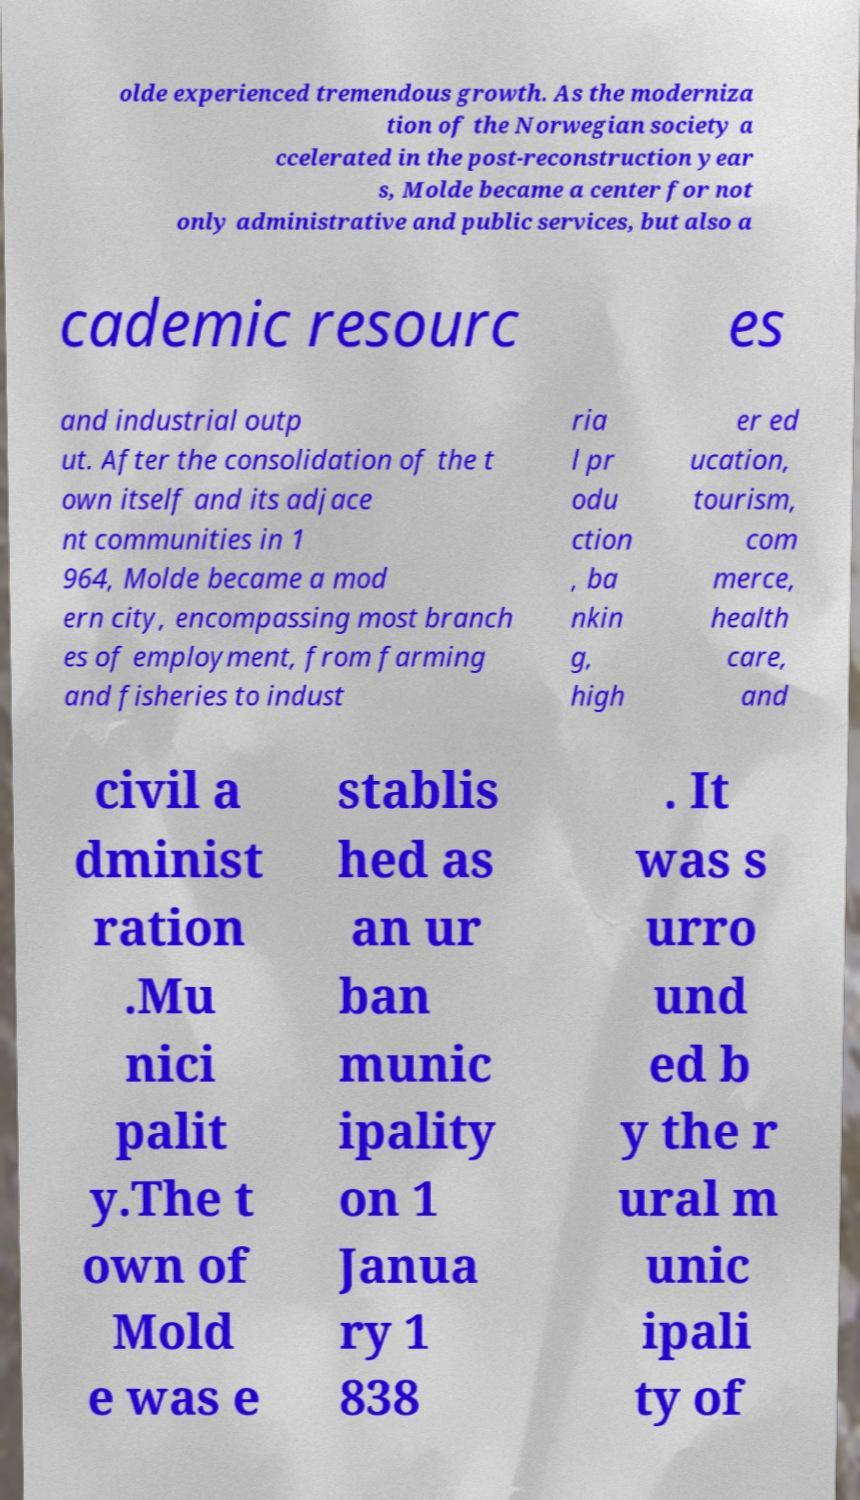Can you accurately transcribe the text from the provided image for me? olde experienced tremendous growth. As the moderniza tion of the Norwegian society a ccelerated in the post-reconstruction year s, Molde became a center for not only administrative and public services, but also a cademic resourc es and industrial outp ut. After the consolidation of the t own itself and its adjace nt communities in 1 964, Molde became a mod ern city, encompassing most branch es of employment, from farming and fisheries to indust ria l pr odu ction , ba nkin g, high er ed ucation, tourism, com merce, health care, and civil a dminist ration .Mu nici palit y.The t own of Mold e was e stablis hed as an ur ban munic ipality on 1 Janua ry 1 838 . It was s urro und ed b y the r ural m unic ipali ty of 